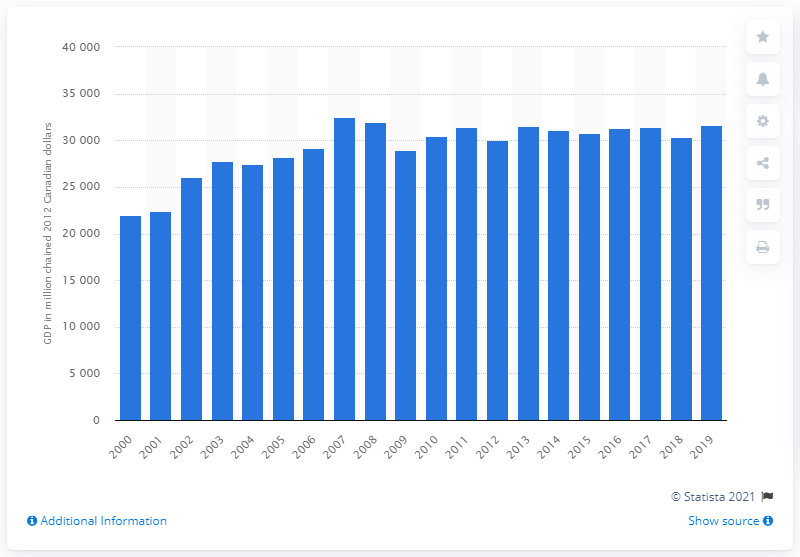Give some essential details in this illustration. In 2019, the Gross Domestic Product (GDP) of Newfoundland and Labrador was 31,588. 